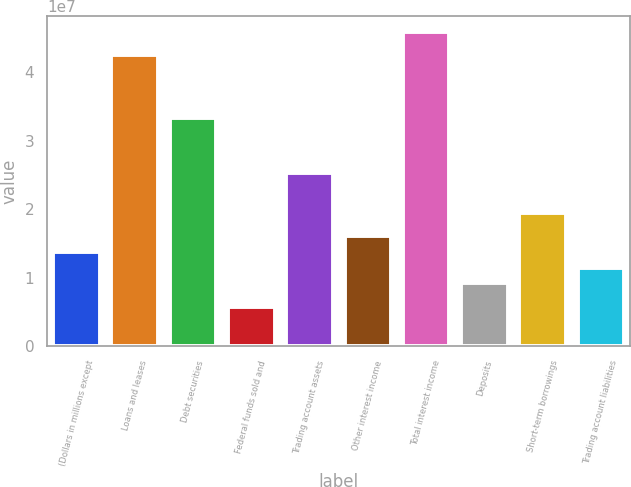Convert chart to OTSL. <chart><loc_0><loc_0><loc_500><loc_500><bar_chart><fcel>(Dollars in millions except<fcel>Loans and leases<fcel>Debt securities<fcel>Federal funds sold and<fcel>Trading account assets<fcel>Other interest income<fcel>Total interest income<fcel>Deposits<fcel>Short-term borrowings<fcel>Trading account liabilities<nl><fcel>1.37897e+07<fcel>4.25182e+07<fcel>3.33251e+07<fcel>5.74571e+06<fcel>2.52811e+07<fcel>1.6088e+07<fcel>4.59657e+07<fcel>9.19313e+06<fcel>1.95354e+07<fcel>1.14914e+07<nl></chart> 